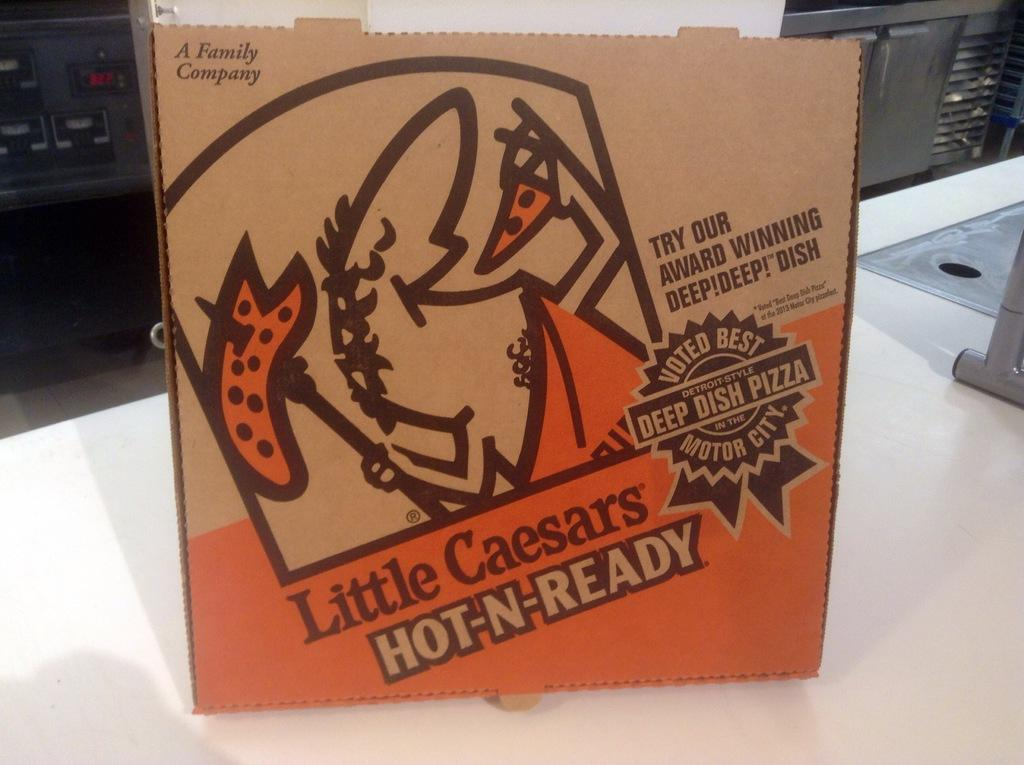<image>
Render a clear and concise summary of the photo. A box of Little Caesars Hot-N-Ready pizza on a white table. 